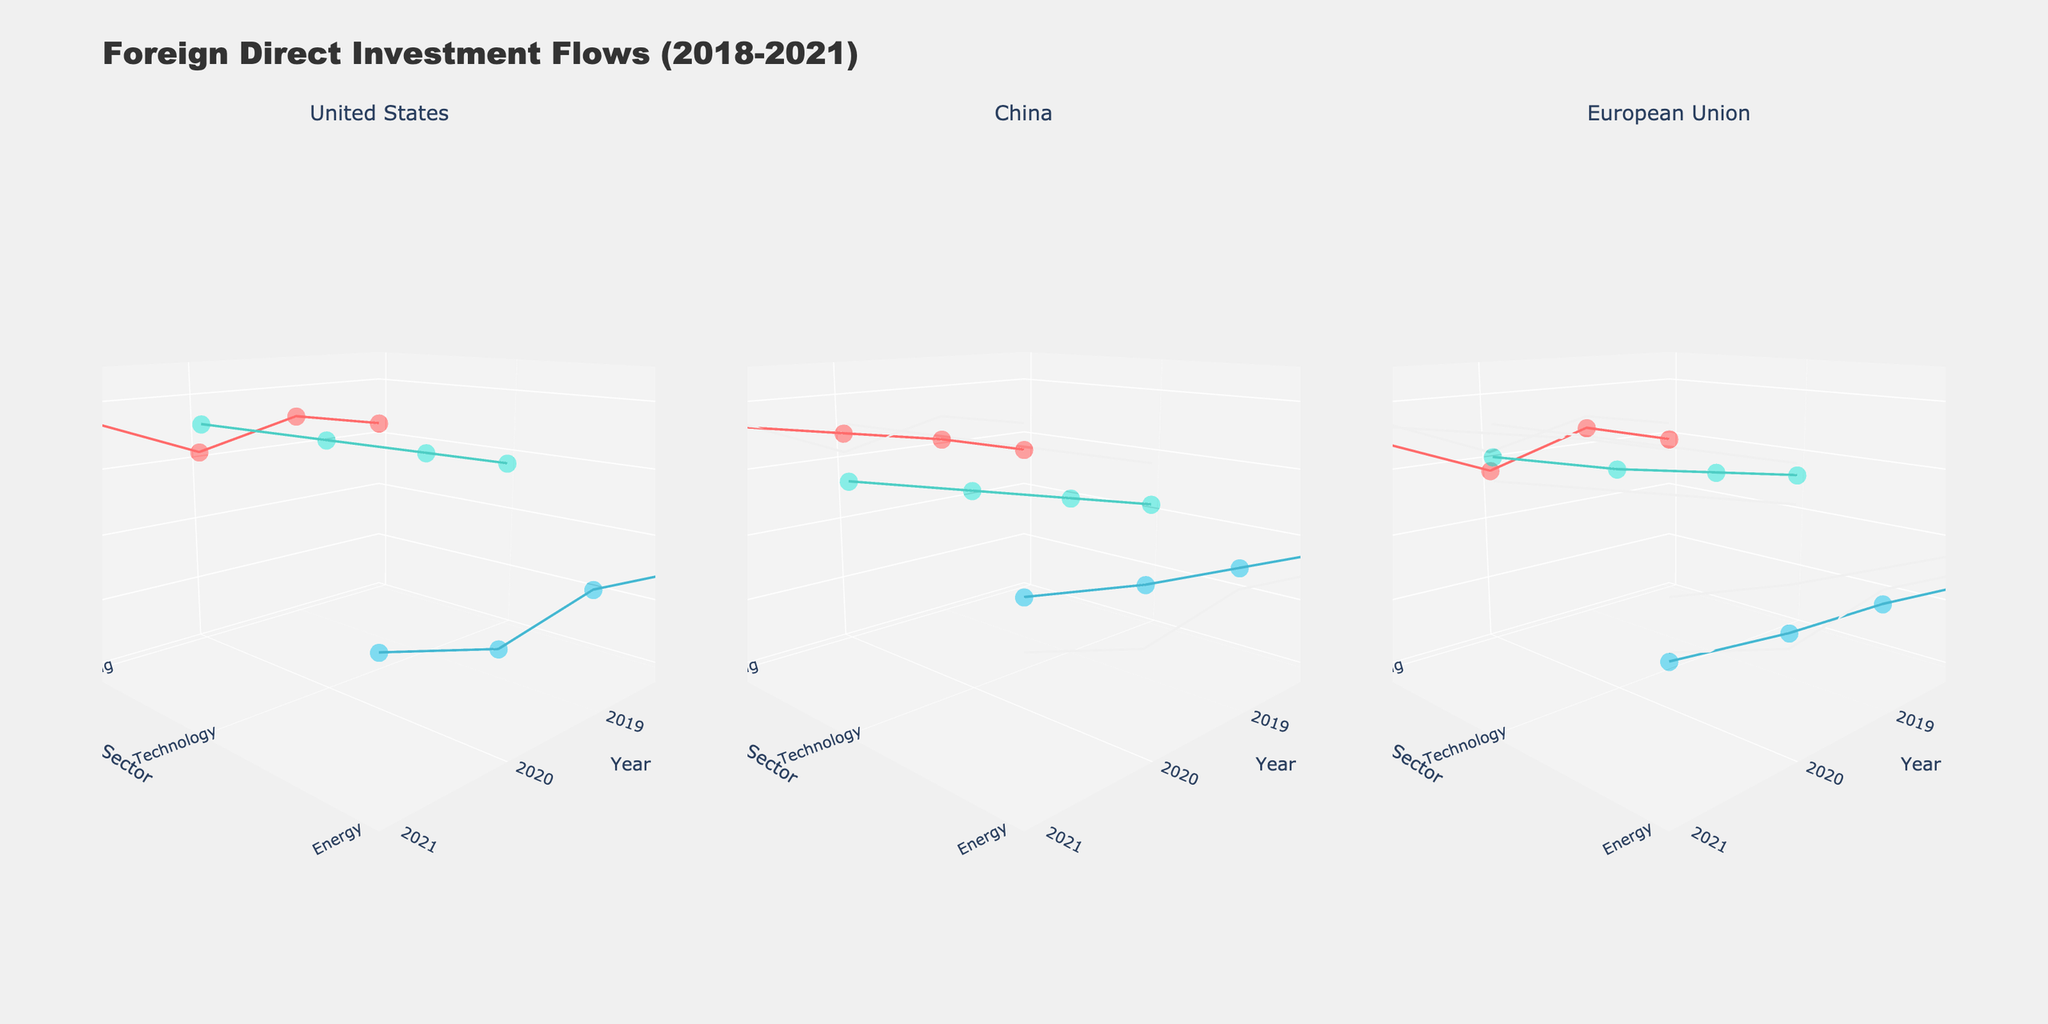What is the title of the figure? The title is displayed at the top of the figure in a larger, bold font to provide a summary of the chart's content.
Answer: Foreign Direct Investment Flows (2018-2021) What year had the highest investment in the technology sector for the United States? In the subplot for the United States, follow the data points for the Technology sector. The highest point on the z-axis corresponds to the year 2021.
Answer: 2021 Which sector received the lowest investment from China in 2020? In the China subplot, locate the data points for the year 2020. Compare the z-axis values for Technology, Manufacturing, and Energy sectors. The Energy sector has the lowest value.
Answer: Energy How did the investment in the Manufacturing sector from the European Union change from 2018 to 2019? In the European Union subplot, follow the data points for the Manufacturing sector from 2018 to 2019. The investment amount increased.
Answer: Increased Compare the Technology sector investments between China and the United States in 2021. Which country had higher investment? In the 2021 data points for the Technology sector in both China and the United States subplots, compare the z-axis values. The United States had higher investment.
Answer: United States Give the average investment amount in the Energy sector from the European Union across all years. Sum the investment amounts from the European Union in the Energy sector for all years: 1300 + 1500 + 1600 + 1800. Divide by the number of years (4) to get the average.
Answer: 1550 Which country showed a consistent increase in Manufacturing sector investments from 2018 to 2021? Check the Manufacturing sector data points over the years for all three countries. Both the United States and China showed consistent increases, whereas the European Union fluctuated.
Answer: United States and China In which year did the Energy sector receive the highest total investment from all three countries? Sum the z-axis values for the Energy sector for each year across the three subplots. Note the year where the sum is the highest.
Answer: 2021 What is the range of the z-axis for all subplots? The z-axis, representing investment amounts, ranges from the lowest to the highest values. The detailed axis labels indicate this range.
Answer: 0 to 4500 Which sector's investment remained nearly equal between China and the European Union in 2021? Compare the z-axis values for all three sectors in 2021 in China and European Union subplots. The values for Manufacturing are the closest.
Answer: Manufacturing 